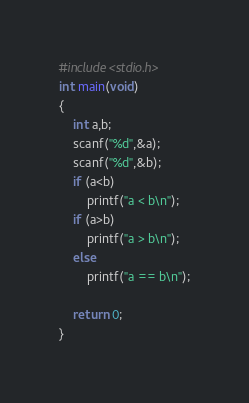<code> <loc_0><loc_0><loc_500><loc_500><_C_>#include<stdio.h>
int main(void)
{
    int a,b;
    scanf("%d",&a);
    scanf("%d",&b);
    if (a<b)
        printf("a < b\n");
    if (a>b)
        printf("a > b\n");
    else
        printf("a == b\n");
    
    return 0;
}
</code> 